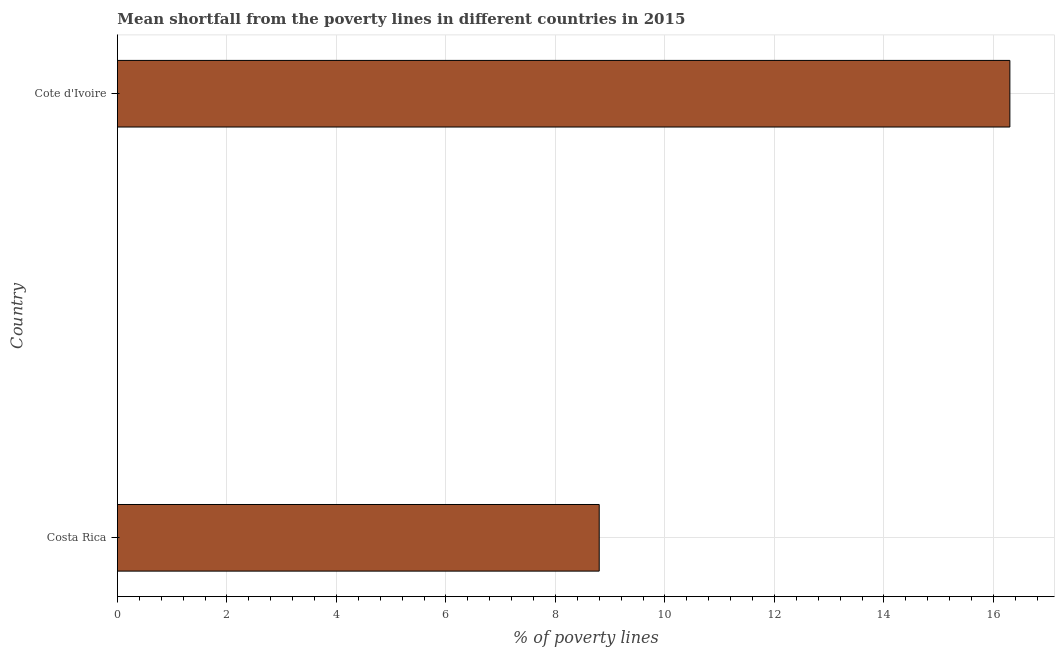What is the title of the graph?
Your answer should be very brief. Mean shortfall from the poverty lines in different countries in 2015. What is the label or title of the X-axis?
Give a very brief answer. % of poverty lines. In which country was the poverty gap at national poverty lines maximum?
Ensure brevity in your answer.  Cote d'Ivoire. What is the sum of the poverty gap at national poverty lines?
Keep it short and to the point. 25.1. What is the average poverty gap at national poverty lines per country?
Your answer should be very brief. 12.55. What is the median poverty gap at national poverty lines?
Give a very brief answer. 12.55. What is the ratio of the poverty gap at national poverty lines in Costa Rica to that in Cote d'Ivoire?
Provide a short and direct response. 0.54. Is the poverty gap at national poverty lines in Costa Rica less than that in Cote d'Ivoire?
Provide a succinct answer. Yes. In how many countries, is the poverty gap at national poverty lines greater than the average poverty gap at national poverty lines taken over all countries?
Keep it short and to the point. 1. What is the difference between two consecutive major ticks on the X-axis?
Your response must be concise. 2. Are the values on the major ticks of X-axis written in scientific E-notation?
Your answer should be compact. No. What is the % of poverty lines in Costa Rica?
Your response must be concise. 8.8. What is the difference between the % of poverty lines in Costa Rica and Cote d'Ivoire?
Give a very brief answer. -7.5. What is the ratio of the % of poverty lines in Costa Rica to that in Cote d'Ivoire?
Make the answer very short. 0.54. 